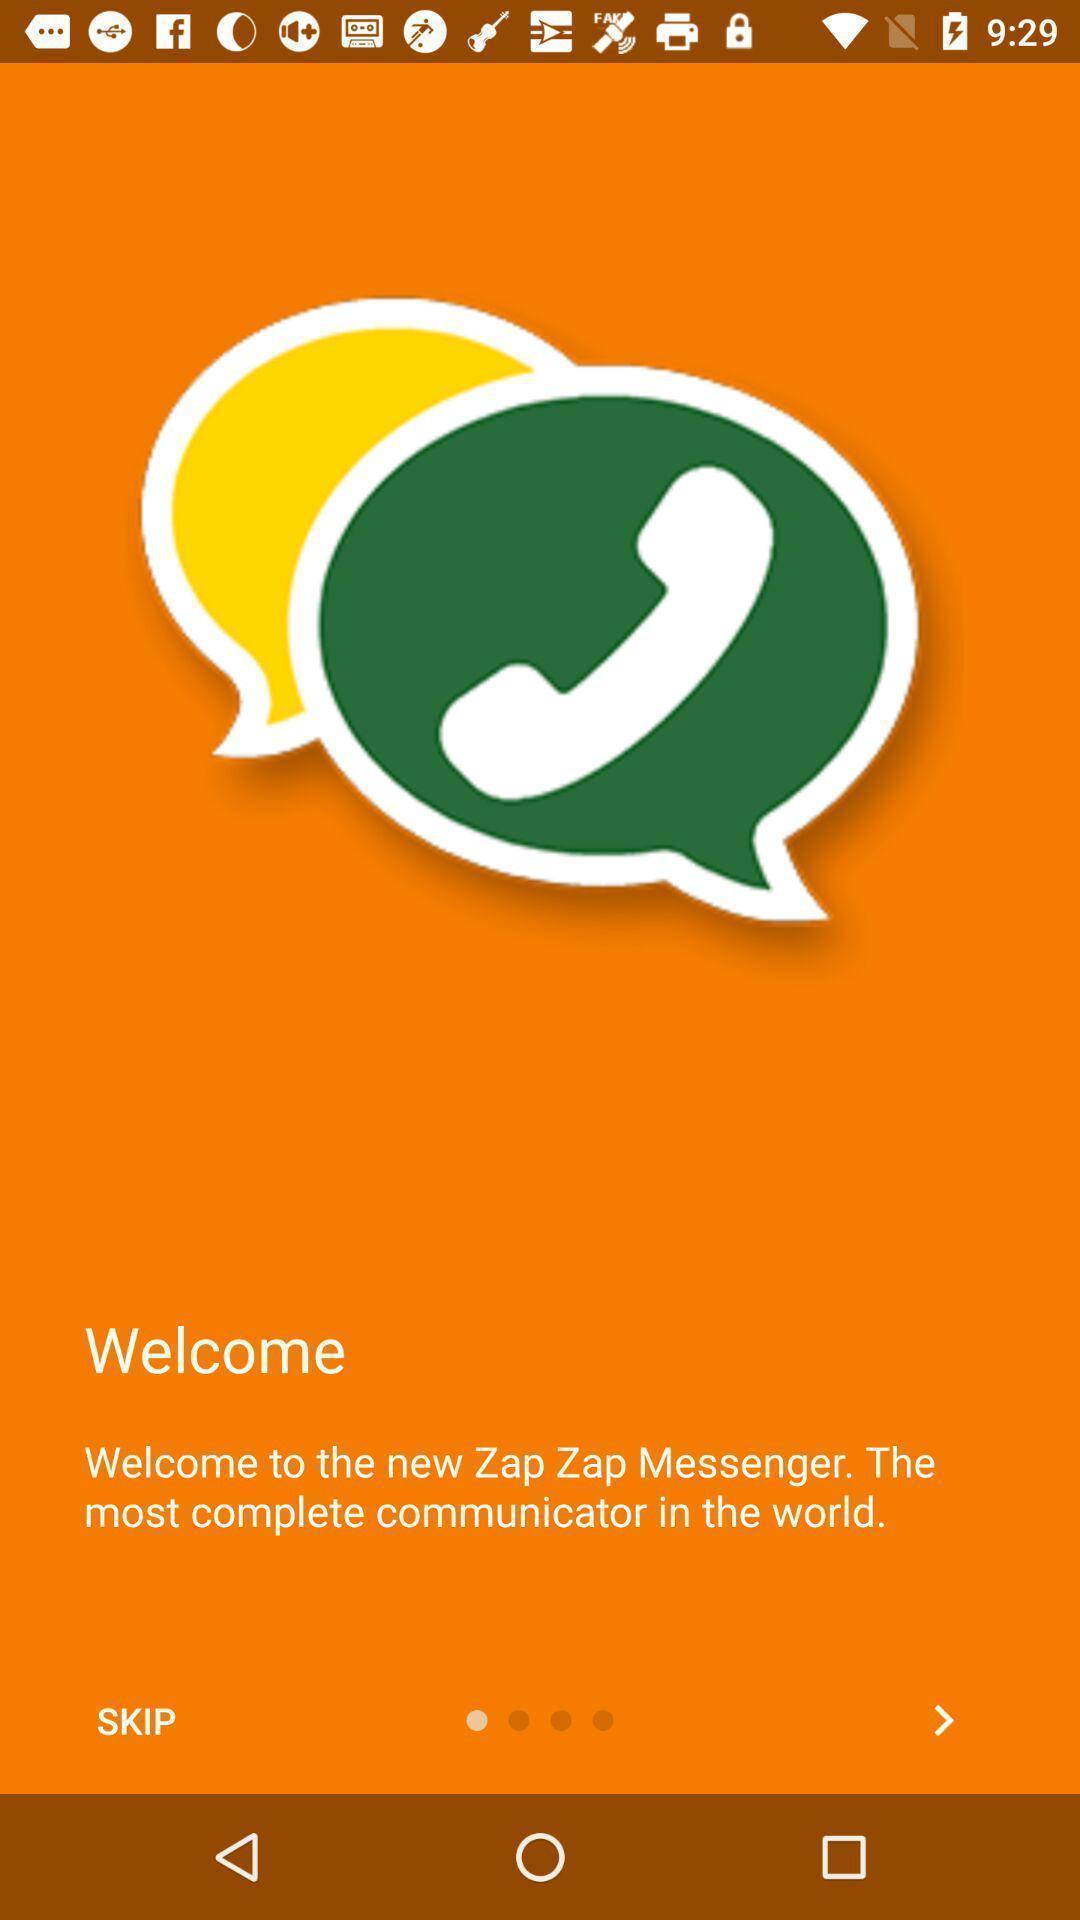Provide a detailed account of this screenshot. Welcome page of the social app. 